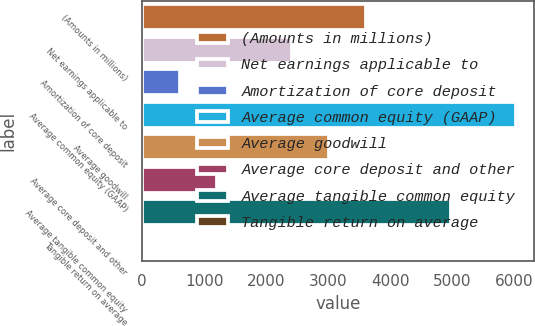Convert chart to OTSL. <chart><loc_0><loc_0><loc_500><loc_500><bar_chart><fcel>(Amounts in millions)<fcel>Net earnings applicable to<fcel>Amortization of core deposit<fcel>Average common equity (GAAP)<fcel>Average goodwill<fcel>Average core deposit and other<fcel>Average tangible common equity<fcel>Tangible return on average<nl><fcel>3617.08<fcel>2413.62<fcel>608.43<fcel>6024<fcel>3015.35<fcel>1210.16<fcel>4979<fcel>6.7<nl></chart> 